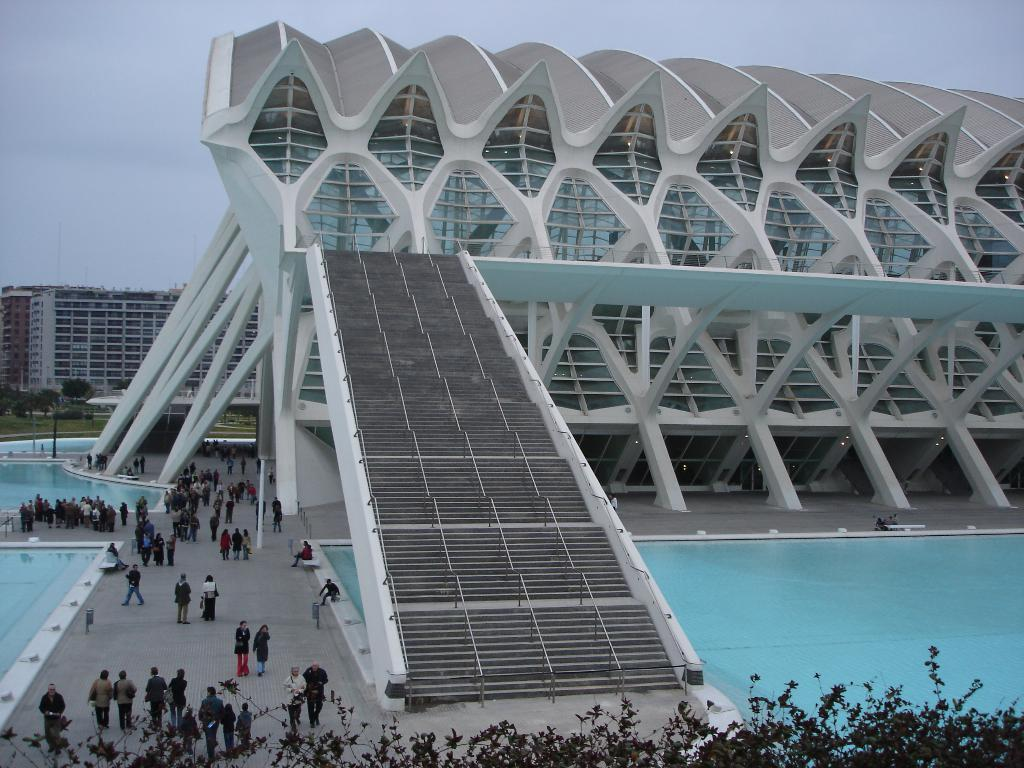What type of structures can be seen in the image? There are buildings in the image. What recreational feature is present in the image? There are swimming pools in the image. What type of vegetation is present in the image? There are trees in the image. What architectural element is present in the image? There are stairs in the image. What safety feature is present in the image? There are railings in the image. Are there any people visible in the image? Yes, there are people standing in the image. What can be seen in the background of the image? The sky is visible in the background of the image. What type of spoon is being used by the writer in the image? There is no writer or spoon present in the image. What type of button is being pressed by the person in the image? There is no button or person pressing a button present in the image. 